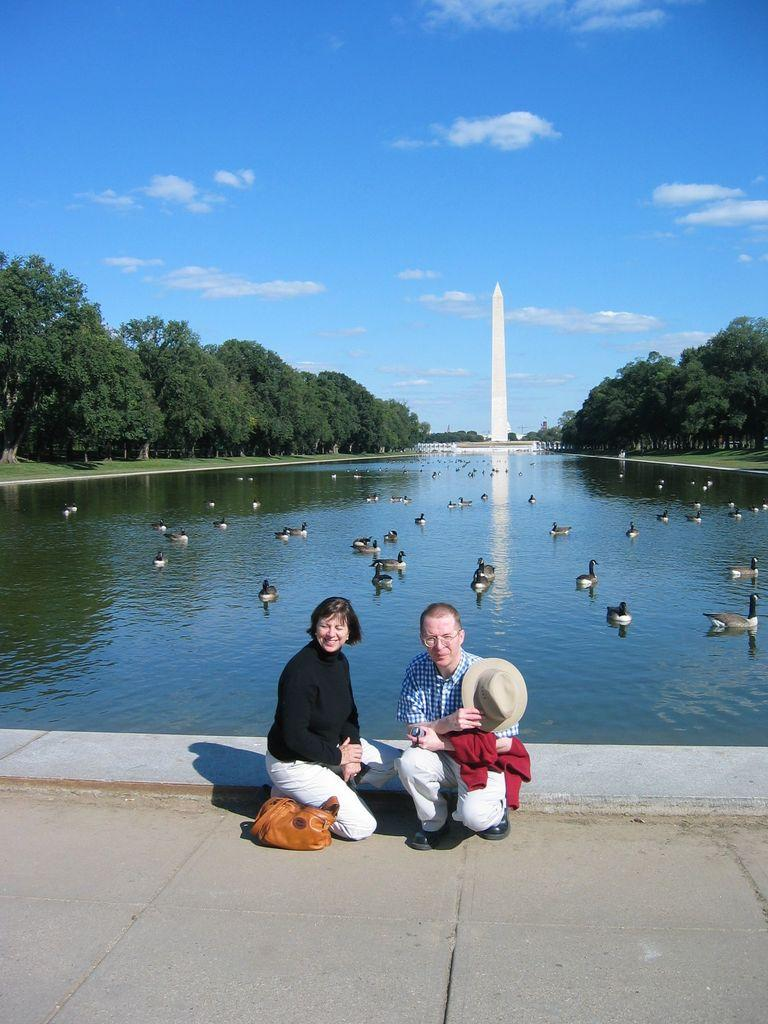What can be seen in the sky in the image? The sky with clouds is visible in the image. What type of vegetation is present in the image? There are trees in the image. What structure can be seen in the image? There is a tower in the image. What animals are on the water in the image? Ducks are present on the water in the image. What are the persons in the image doing? There are persons sitting on the floor in the image. What type of mask is being worn by the ducks in the image? There are no masks present in the image, and the ducks are not wearing any. How many mittens can be seen on the persons sitting on the floor in the image? There is no mention of mittens in the image, and none are visible. 